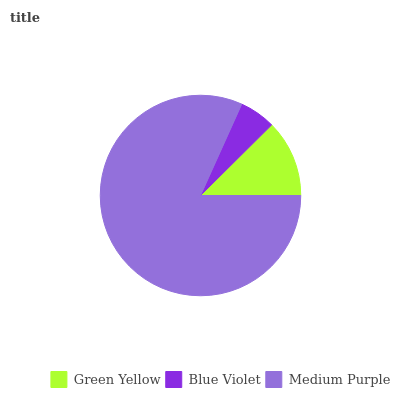Is Blue Violet the minimum?
Answer yes or no. Yes. Is Medium Purple the maximum?
Answer yes or no. Yes. Is Medium Purple the minimum?
Answer yes or no. No. Is Blue Violet the maximum?
Answer yes or no. No. Is Medium Purple greater than Blue Violet?
Answer yes or no. Yes. Is Blue Violet less than Medium Purple?
Answer yes or no. Yes. Is Blue Violet greater than Medium Purple?
Answer yes or no. No. Is Medium Purple less than Blue Violet?
Answer yes or no. No. Is Green Yellow the high median?
Answer yes or no. Yes. Is Green Yellow the low median?
Answer yes or no. Yes. Is Blue Violet the high median?
Answer yes or no. No. Is Blue Violet the low median?
Answer yes or no. No. 